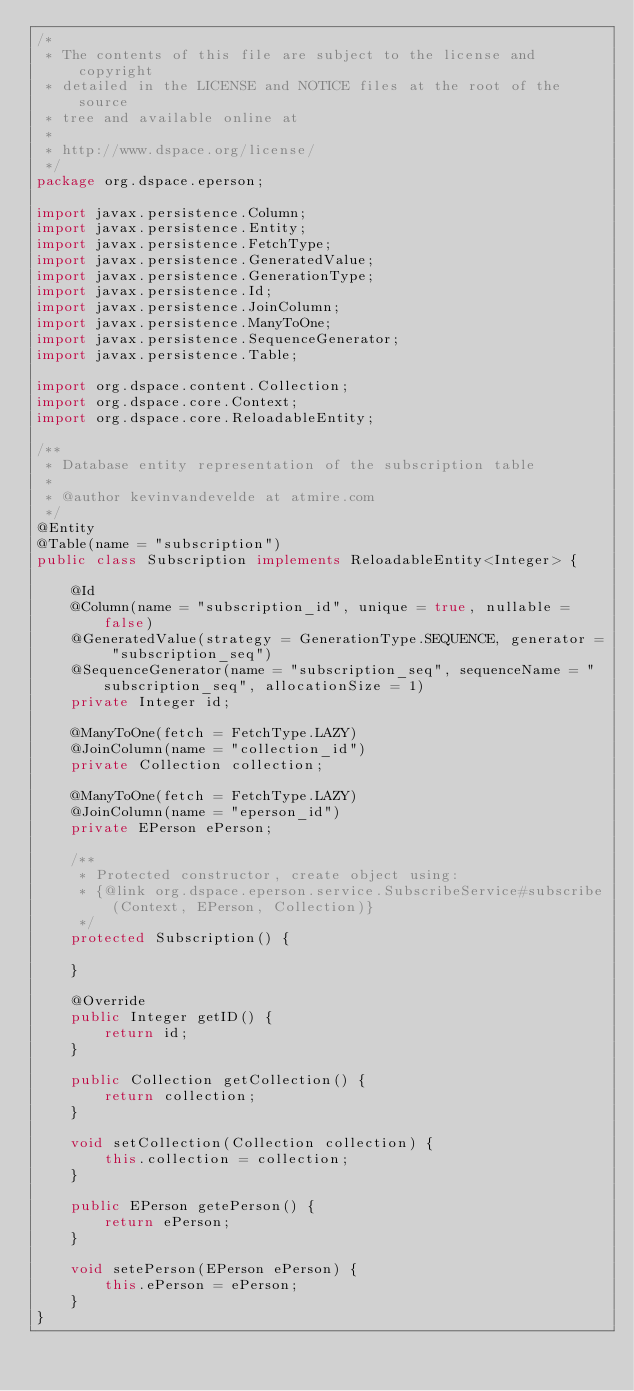Convert code to text. <code><loc_0><loc_0><loc_500><loc_500><_Java_>/*
 * The contents of this file are subject to the license and copyright
 * detailed in the LICENSE and NOTICE files at the root of the source
 * tree and available online at
 *
 * http://www.dspace.org/license/
 */
package org.dspace.eperson;

import javax.persistence.Column;
import javax.persistence.Entity;
import javax.persistence.FetchType;
import javax.persistence.GeneratedValue;
import javax.persistence.GenerationType;
import javax.persistence.Id;
import javax.persistence.JoinColumn;
import javax.persistence.ManyToOne;
import javax.persistence.SequenceGenerator;
import javax.persistence.Table;

import org.dspace.content.Collection;
import org.dspace.core.Context;
import org.dspace.core.ReloadableEntity;

/**
 * Database entity representation of the subscription table
 *
 * @author kevinvandevelde at atmire.com
 */
@Entity
@Table(name = "subscription")
public class Subscription implements ReloadableEntity<Integer> {

    @Id
    @Column(name = "subscription_id", unique = true, nullable = false)
    @GeneratedValue(strategy = GenerationType.SEQUENCE, generator = "subscription_seq")
    @SequenceGenerator(name = "subscription_seq", sequenceName = "subscription_seq", allocationSize = 1)
    private Integer id;

    @ManyToOne(fetch = FetchType.LAZY)
    @JoinColumn(name = "collection_id")
    private Collection collection;

    @ManyToOne(fetch = FetchType.LAZY)
    @JoinColumn(name = "eperson_id")
    private EPerson ePerson;

    /**
     * Protected constructor, create object using:
     * {@link org.dspace.eperson.service.SubscribeService#subscribe(Context, EPerson, Collection)}
     */
    protected Subscription() {

    }

    @Override
    public Integer getID() {
        return id;
    }

    public Collection getCollection() {
        return collection;
    }

    void setCollection(Collection collection) {
        this.collection = collection;
    }

    public EPerson getePerson() {
        return ePerson;
    }

    void setePerson(EPerson ePerson) {
        this.ePerson = ePerson;
    }
}
</code> 